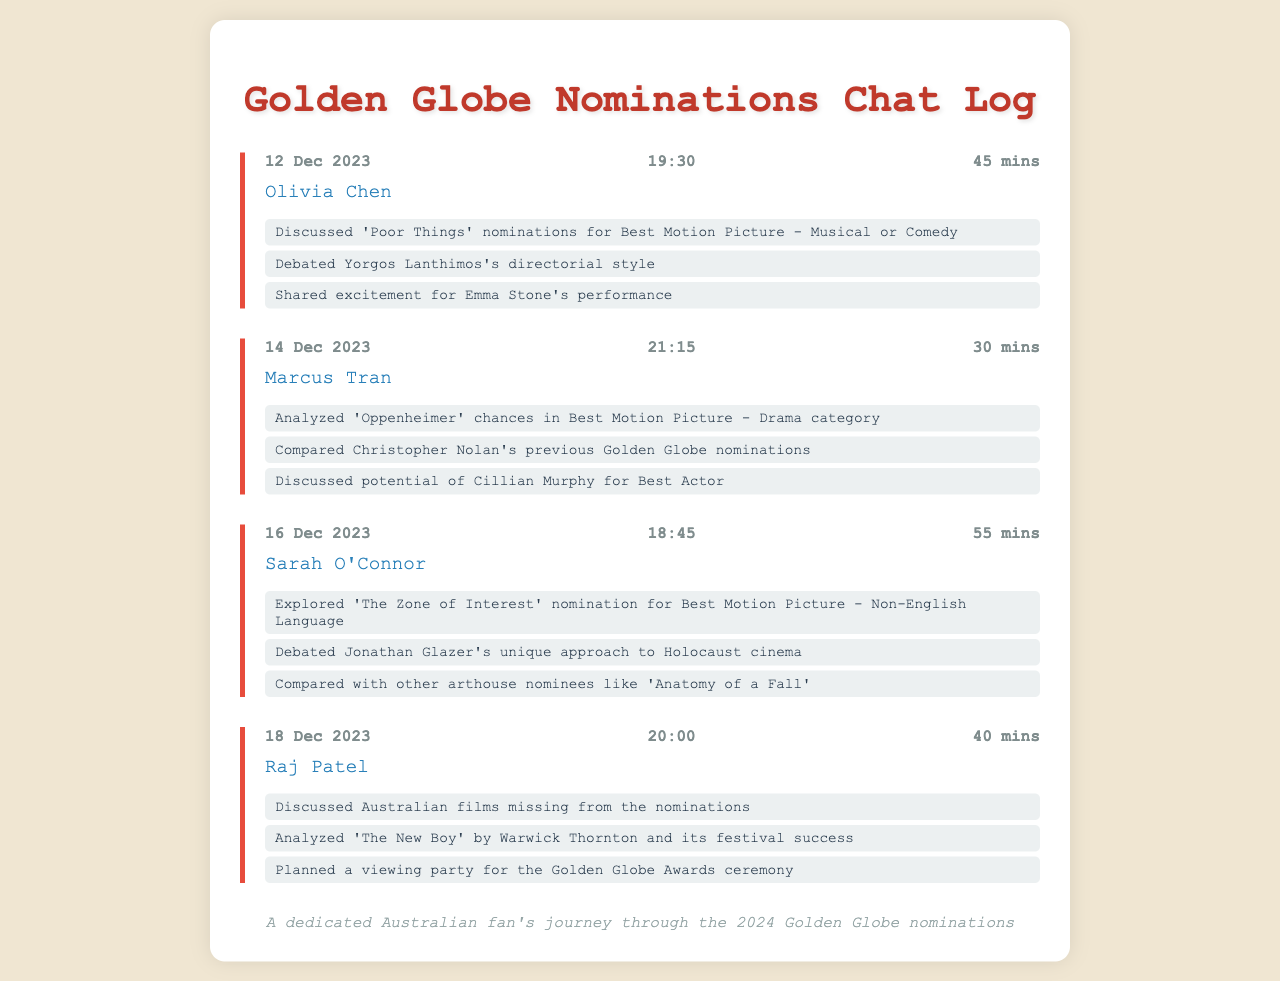What was the date of the call with Olivia Chen? The document lists the date of the call with Olivia Chen as 12 Dec 2023.
Answer: 12 Dec 2023 Who was discussed in relation to 'Oppenheimer'? The call with Marcus Tran analyzed the potential of Cillian Murphy for Best Actor in relation to 'Oppenheimer'.
Answer: Cillian Murphy What was the duration of the call with Sarah O'Connor? The call duration with Sarah O'Connor is listed as 55 mins.
Answer: 55 mins Which film was mentioned as a nominee for Best Motion Picture - Non-English Language? The document states that 'The Zone of Interest' was discussed as a nominee for Best Motion Picture - Non-English Language.
Answer: The Zone of Interest What common theme is evident in the calls? The calls focus on discussing nominations and performances related to films in the Golden Globes.
Answer: Nominations and performances Which film's directorial style was debated during the call with Olivia Chen? The directorial style discussed during the call with Olivia Chen was Yorgos Lanthimos's.
Answer: Yorgos Lanthimos What is the planned event mentioned in the call with Raj Patel? Raj Patel discussed planning a viewing party for the Golden Globe Awards ceremony.
Answer: Viewing party How many minutes long was the call with Marcus Tran? The call with Marcus Tran was recorded for 30 minutes.
Answer: 30 mins 